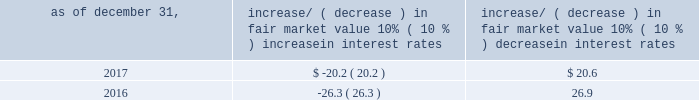Item 7a .
Quantitative and qualitative disclosures about market risk ( amounts in millions ) in the normal course of business , we are exposed to market risks related to interest rates , foreign currency rates and certain balance sheet items .
From time to time , we use derivative instruments , pursuant to established guidelines and policies , to manage some portion of these risks .
Derivative instruments utilized in our hedging activities are viewed as risk management tools and are not used for trading or speculative purposes .
Interest rates our exposure to market risk for changes in interest rates relates primarily to the fair market value and cash flows of our debt obligations .
The majority of our debt ( approximately 94% ( 94 % ) and 93% ( 93 % ) as of december 31 , 2017 and 2016 , respectively ) bears interest at fixed rates .
We do have debt with variable interest rates , but a 10% ( 10 % ) increase or decrease in interest rates would not be material to our interest expense or cash flows .
The fair market value of our debt is sensitive to changes in interest rates , and the impact of a 10% ( 10 % ) change in interest rates is summarized below .
Increase/ ( decrease ) in fair market value as of december 31 , 10% ( 10 % ) increase in interest rates 10% ( 10 % ) decrease in interest rates .
We have used interest rate swaps for risk management purposes to manage our exposure to changes in interest rates .
We did not have any interest rate swaps outstanding as of december 31 , 2017 .
We had $ 791.0 of cash , cash equivalents and marketable securities as of december 31 , 2017 that we generally invest in conservative , short-term bank deposits or securities .
The interest income generated from these investments is subject to both domestic and foreign interest rate movements .
During 2017 and 2016 , we had interest income of $ 19.4 and $ 20.1 , respectively .
Based on our 2017 results , a 100 basis-point increase or decrease in interest rates would affect our interest income by approximately $ 7.9 , assuming that all cash , cash equivalents and marketable securities are impacted in the same manner and balances remain constant from year-end 2017 levels .
Foreign currency rates we are subject to translation and transaction risks related to changes in foreign currency exchange rates .
Since we report revenues and expenses in u.s .
Dollars , changes in exchange rates may either positively or negatively affect our consolidated revenues and expenses ( as expressed in u.s .
Dollars ) from foreign operations .
The foreign currencies that most impacted our results during 2017 included the british pound sterling and , to a lesser extent , brazilian real and south african rand .
Based on 2017 exchange rates and operating results , if the u.s .
Dollar were to strengthen or weaken by 10% ( 10 % ) , we currently estimate operating income would decrease or increase approximately 4% ( 4 % ) , assuming that all currencies are impacted in the same manner and our international revenue and expenses remain constant at 2017 levels .
The functional currency of our foreign operations is generally their respective local currency .
Assets and liabilities are translated at the exchange rates in effect at the balance sheet date , and revenues and expenses are translated at the average exchange rates during the period presented .
The resulting translation adjustments are recorded as a component of accumulated other comprehensive loss , net of tax , in the stockholders 2019 equity section of our consolidated balance sheets .
Our foreign subsidiaries generally collect revenues and pay expenses in their functional currency , mitigating transaction risk .
However , certain subsidiaries may enter into transactions in currencies other than their functional currency .
Assets and liabilities denominated in currencies other than the functional currency are susceptible to movements in foreign currency until final settlement .
Currency transaction gains or losses primarily arising from transactions in currencies other than the functional currency are included in office and general expenses .
We regularly review our foreign exchange exposures that may have a material impact on our business and from time to time use foreign currency forward exchange contracts or other derivative financial instruments to hedge the effects of potential adverse fluctuations in foreign currency exchange rates arising from these exposures .
We do not enter into foreign exchange contracts or other derivatives for speculative purposes. .
What was the average interest income from 2016 and 2017 , in millions? 
Computations: ((19.4 + 20.1) / 2)
Answer: 19.75. 